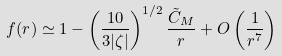<formula> <loc_0><loc_0><loc_500><loc_500>f ( r ) \simeq 1 - \left ( \frac { 1 0 } { 3 | \zeta | } \right ) ^ { 1 / 2 } \frac { \tilde { C } _ { M } } { r } + O \left ( \frac { 1 } { r ^ { 7 } } \right )</formula> 